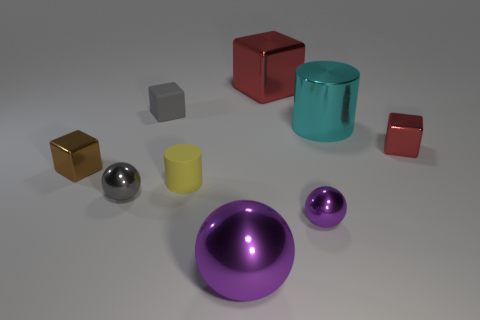What size is the cylinder that is behind the brown metal thing that is on the left side of the red metal cube behind the cyan thing?
Keep it short and to the point. Large. What is the material of the tiny yellow cylinder?
Your response must be concise. Rubber. There is a brown metal block; are there any small things in front of it?
Provide a succinct answer. Yes. Is the yellow object the same shape as the big purple metallic object?
Ensure brevity in your answer.  No. How many other things are the same size as the brown metal thing?
Offer a very short reply. 5. How many objects are large objects that are behind the tiny brown shiny block or tiny cyan things?
Offer a terse response. 2. What is the color of the tiny cylinder?
Provide a short and direct response. Yellow. What material is the red thing on the left side of the big cyan thing?
Provide a short and direct response. Metal. There is a yellow thing; is it the same shape as the large thing that is in front of the tiny red shiny thing?
Keep it short and to the point. No. Are there more yellow metallic blocks than tiny purple shiny objects?
Your response must be concise. No. 